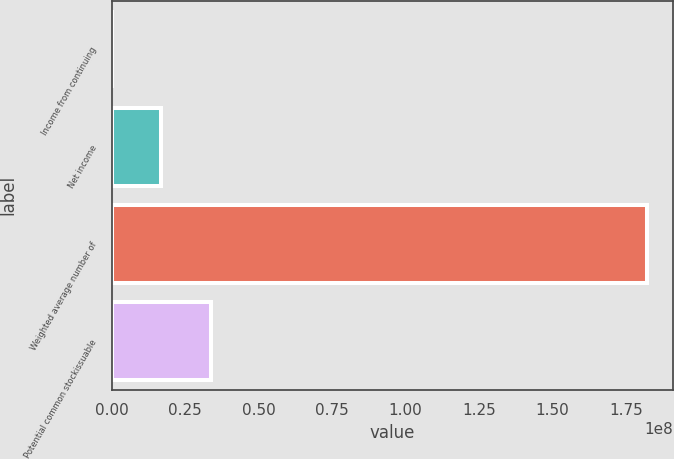<chart> <loc_0><loc_0><loc_500><loc_500><bar_chart><fcel>Income from continuing<fcel>Net income<fcel>Weighted average number of<fcel>Potential common stockissuable<nl><fcel>555.1<fcel>1.68694e+07<fcel>1.82037e+08<fcel>3.37382e+07<nl></chart> 